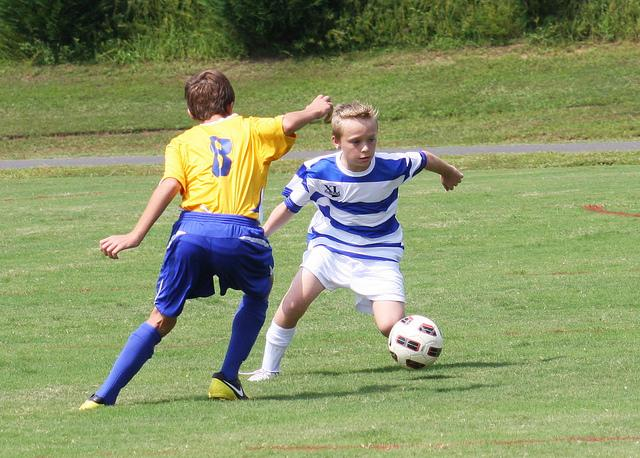What is the boy in blue and white trying to do? Please explain your reasoning. kick ball. The boys are kicking the ball. 